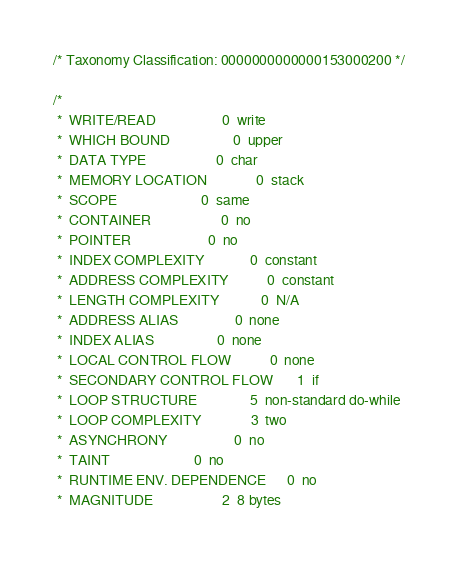Convert code to text. <code><loc_0><loc_0><loc_500><loc_500><_C_>/* Taxonomy Classification: 0000000000000153000200 */

/*
 *  WRITE/READ               	 0	write
 *  WHICH BOUND              	 0	upper
 *  DATA TYPE                	 0	char
 *  MEMORY LOCATION          	 0	stack
 *  SCOPE                    	 0	same
 *  CONTAINER                	 0	no
 *  POINTER                  	 0	no
 *  INDEX COMPLEXITY         	 0	constant
 *  ADDRESS COMPLEXITY       	 0	constant
 *  LENGTH COMPLEXITY        	 0	N/A
 *  ADDRESS ALIAS            	 0	none
 *  INDEX ALIAS              	 0	none
 *  LOCAL CONTROL FLOW       	 0	none
 *  SECONDARY CONTROL FLOW   	 1	if
 *  LOOP STRUCTURE           	 5	non-standard do-while
 *  LOOP COMPLEXITY          	 3	two
 *  ASYNCHRONY               	 0	no
 *  TAINT                    	 0	no
 *  RUNTIME ENV. DEPENDENCE  	 0	no
 *  MAGNITUDE                	 2	8 bytes</code> 